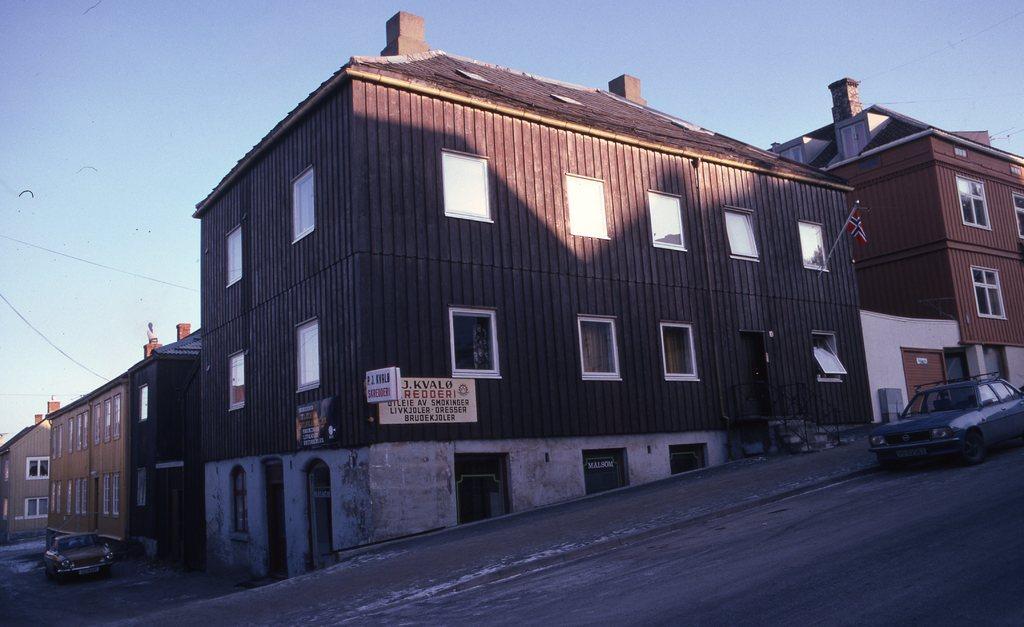Please provide a concise description of this image. As we can see in the image there are buildings, cars, windows and banners. On the top there is a sky. 